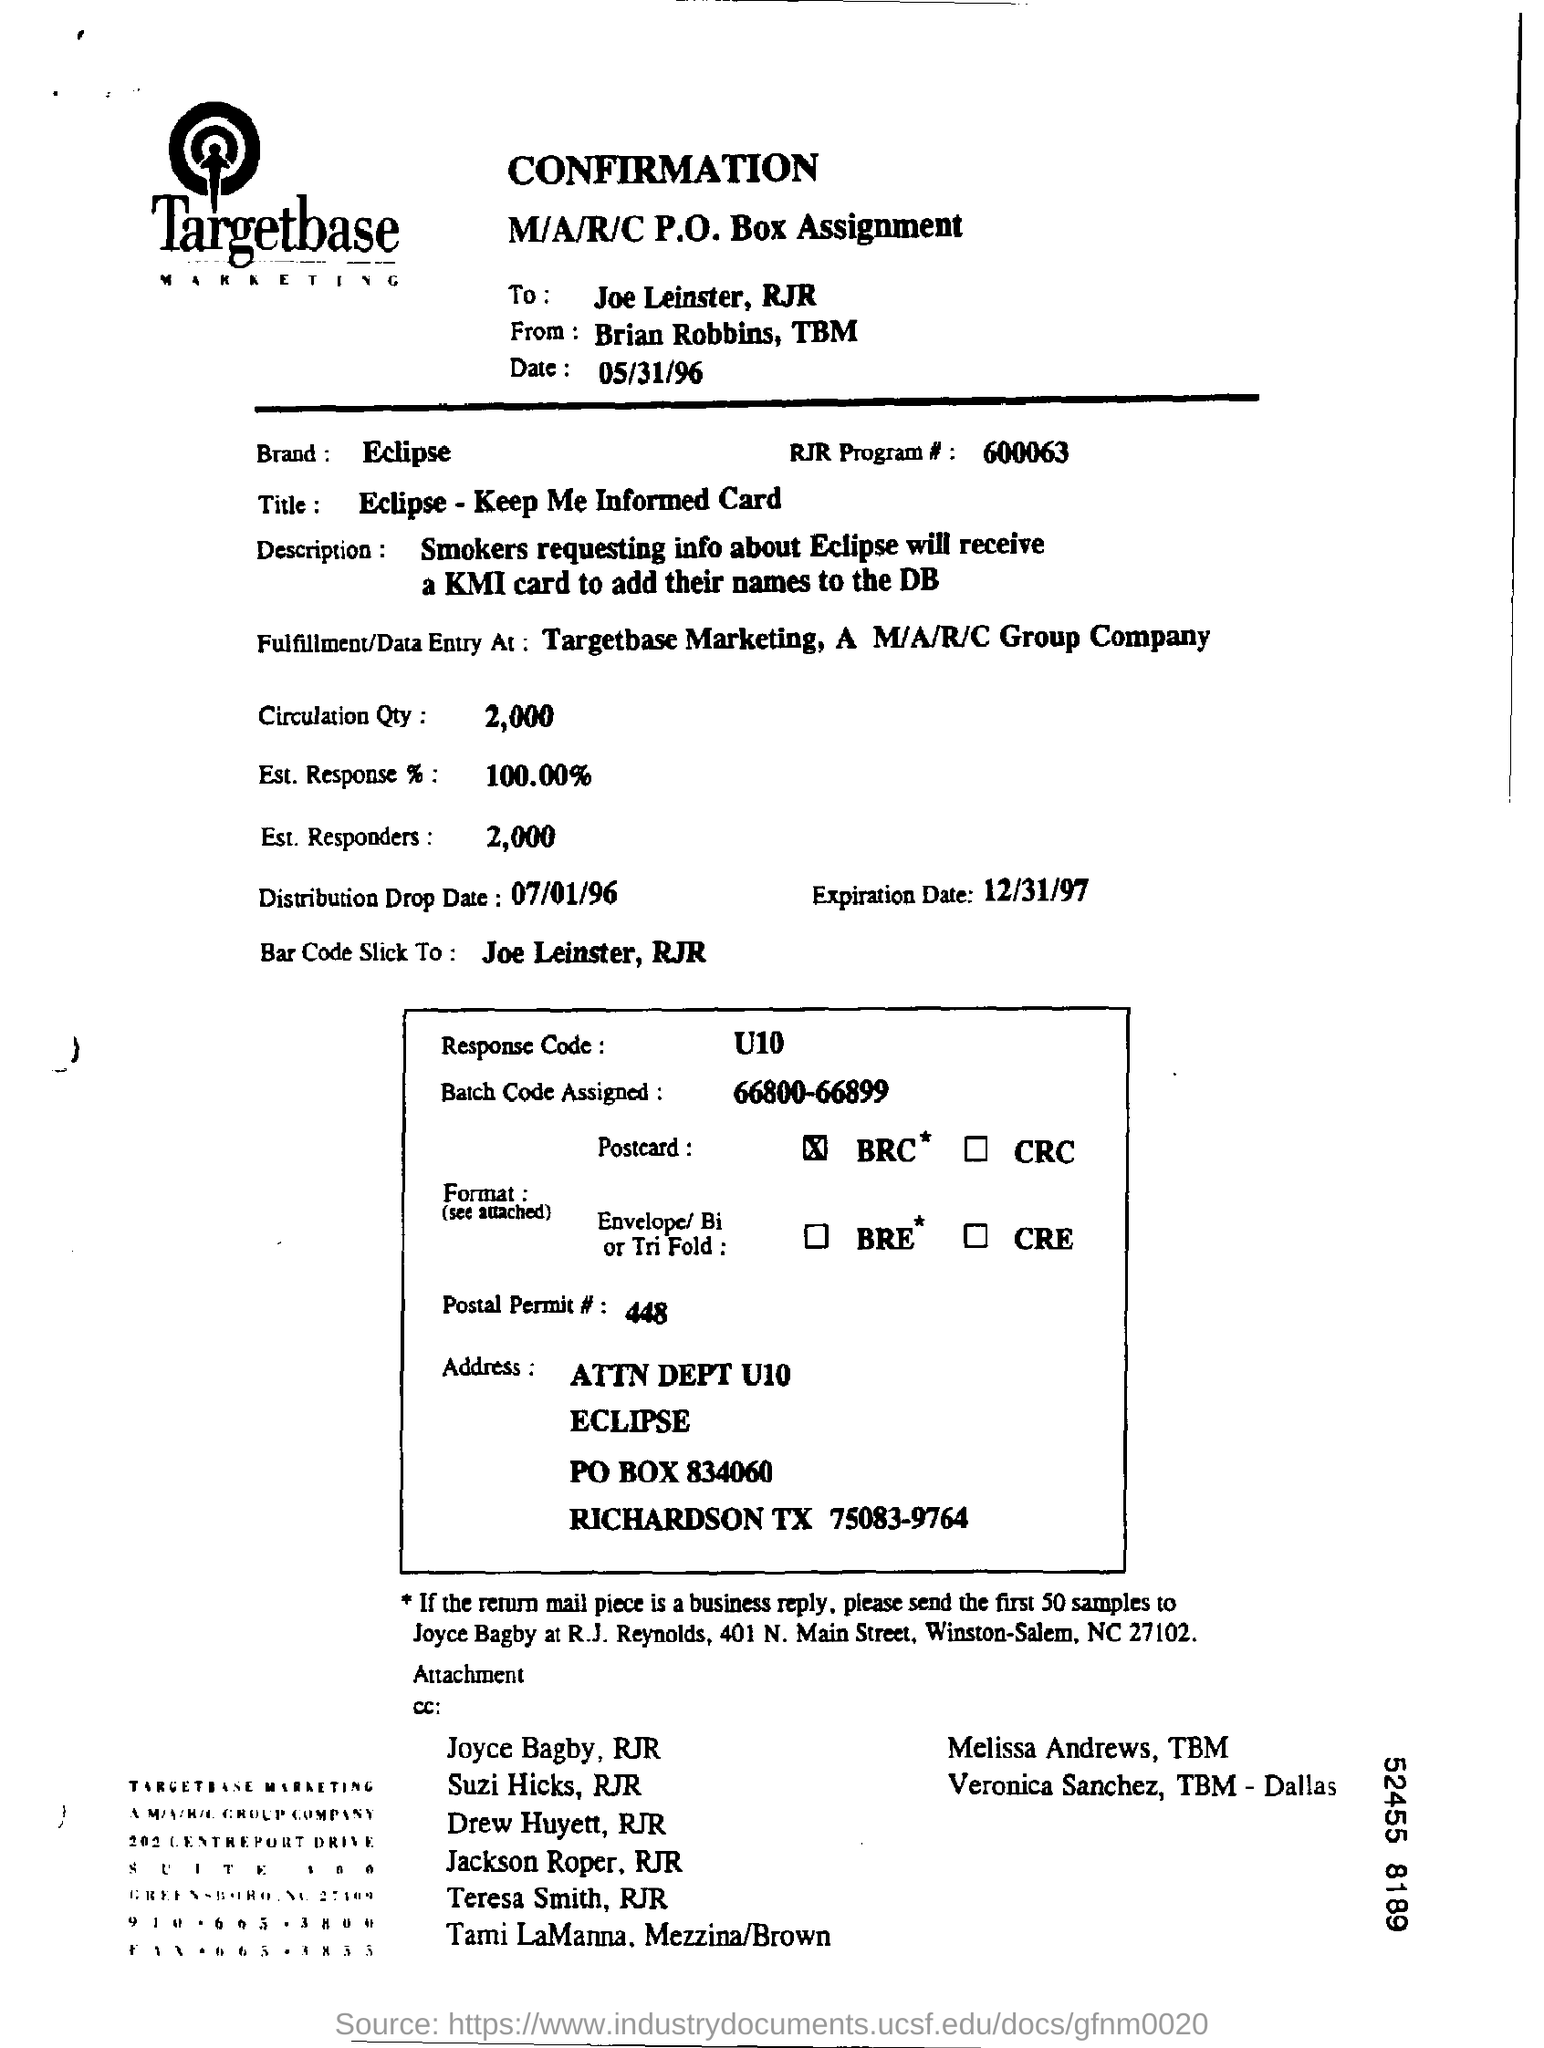Specify some key components in this picture. The brand name is Eclipse. The batch code that has been assigned is between 66800 and 66899. The circulation quantity is approximately 2,000. The bar code is attached to Joe Leinster, RJr. 